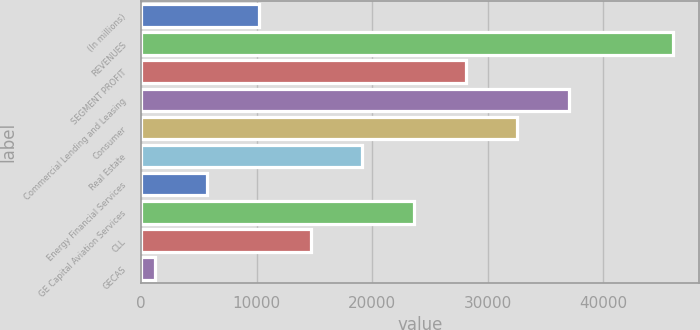Convert chart to OTSL. <chart><loc_0><loc_0><loc_500><loc_500><bar_chart><fcel>(In millions)<fcel>REVENUES<fcel>SEGMENT PROFIT<fcel>Commercial Lending and Leasing<fcel>Consumer<fcel>Real Estate<fcel>Energy Financial Services<fcel>GE Capital Aviation Services<fcel>CLL<fcel>GECAS<nl><fcel>10183.8<fcel>46039<fcel>28111.4<fcel>37075.2<fcel>32593.3<fcel>19147.6<fcel>5701.9<fcel>23629.5<fcel>14665.7<fcel>1220<nl></chart> 